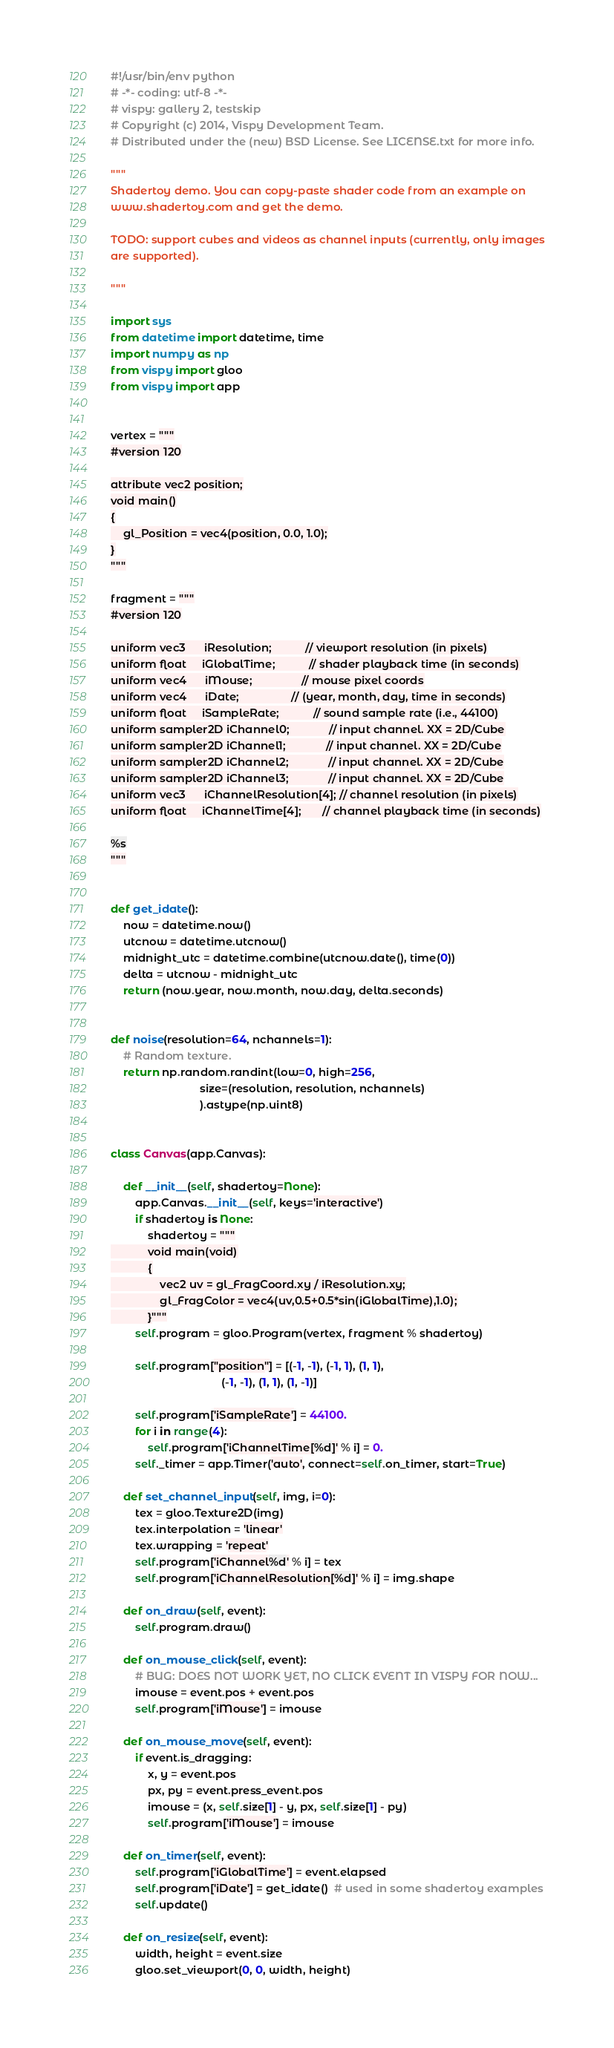<code> <loc_0><loc_0><loc_500><loc_500><_Python_>#!/usr/bin/env python
# -*- coding: utf-8 -*-
# vispy: gallery 2, testskip
# Copyright (c) 2014, Vispy Development Team.
# Distributed under the (new) BSD License. See LICENSE.txt for more info.

"""
Shadertoy demo. You can copy-paste shader code from an example on
www.shadertoy.com and get the demo.

TODO: support cubes and videos as channel inputs (currently, only images
are supported).

"""

import sys
from datetime import datetime, time
import numpy as np
from vispy import gloo
from vispy import app


vertex = """
#version 120

attribute vec2 position;
void main()
{
    gl_Position = vec4(position, 0.0, 1.0);
}
"""

fragment = """
#version 120

uniform vec3      iResolution;           // viewport resolution (in pixels)
uniform float     iGlobalTime;           // shader playback time (in seconds)
uniform vec4      iMouse;                // mouse pixel coords
uniform vec4      iDate;                 // (year, month, day, time in seconds)
uniform float     iSampleRate;           // sound sample rate (i.e., 44100)
uniform sampler2D iChannel0;             // input channel. XX = 2D/Cube
uniform sampler2D iChannel1;             // input channel. XX = 2D/Cube
uniform sampler2D iChannel2;             // input channel. XX = 2D/Cube
uniform sampler2D iChannel3;             // input channel. XX = 2D/Cube
uniform vec3      iChannelResolution[4]; // channel resolution (in pixels)
uniform float     iChannelTime[4];       // channel playback time (in seconds)

%s
"""


def get_idate():
    now = datetime.now()
    utcnow = datetime.utcnow()
    midnight_utc = datetime.combine(utcnow.date(), time(0))
    delta = utcnow - midnight_utc
    return (now.year, now.month, now.day, delta.seconds)


def noise(resolution=64, nchannels=1):
    # Random texture.
    return np.random.randint(low=0, high=256, 
                             size=(resolution, resolution, nchannels)
                             ).astype(np.uint8)


class Canvas(app.Canvas):

    def __init__(self, shadertoy=None):
        app.Canvas.__init__(self, keys='interactive')
        if shadertoy is None:
            shadertoy = """
            void main(void)
            {
                vec2 uv = gl_FragCoord.xy / iResolution.xy;
                gl_FragColor = vec4(uv,0.5+0.5*sin(iGlobalTime),1.0);
            }"""
        self.program = gloo.Program(vertex, fragment % shadertoy)

        self.program["position"] = [(-1, -1), (-1, 1), (1, 1),
                                    (-1, -1), (1, 1), (1, -1)]

        self.program['iSampleRate'] = 44100.
        for i in range(4):
            self.program['iChannelTime[%d]' % i] = 0.
        self._timer = app.Timer('auto', connect=self.on_timer, start=True)

    def set_channel_input(self, img, i=0):
        tex = gloo.Texture2D(img)
        tex.interpolation = 'linear'
        tex.wrapping = 'repeat'
        self.program['iChannel%d' % i] = tex
        self.program['iChannelResolution[%d]' % i] = img.shape
        
    def on_draw(self, event):
        self.program.draw()

    def on_mouse_click(self, event):
        # BUG: DOES NOT WORK YET, NO CLICK EVENT IN VISPY FOR NOW...
        imouse = event.pos + event.pos
        self.program['iMouse'] = imouse

    def on_mouse_move(self, event):
        if event.is_dragging:
            x, y = event.pos
            px, py = event.press_event.pos
            imouse = (x, self.size[1] - y, px, self.size[1] - py)
            self.program['iMouse'] = imouse
        
    def on_timer(self, event):
        self.program['iGlobalTime'] = event.elapsed
        self.program['iDate'] = get_idate()  # used in some shadertoy examples
        self.update()
        
    def on_resize(self, event):
        width, height = event.size
        gloo.set_viewport(0, 0, width, height)</code> 